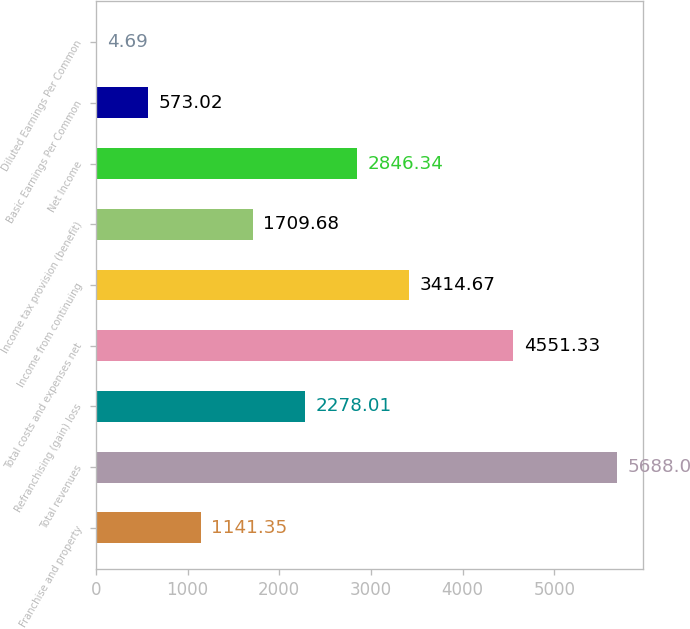Convert chart. <chart><loc_0><loc_0><loc_500><loc_500><bar_chart><fcel>Franchise and property<fcel>Total revenues<fcel>Refranchising (gain) loss<fcel>Total costs and expenses net<fcel>Income from continuing<fcel>Income tax provision (benefit)<fcel>Net Income<fcel>Basic Earnings Per Common<fcel>Diluted Earnings Per Common<nl><fcel>1141.35<fcel>5688<fcel>2278.01<fcel>4551.33<fcel>3414.67<fcel>1709.68<fcel>2846.34<fcel>573.02<fcel>4.69<nl></chart> 